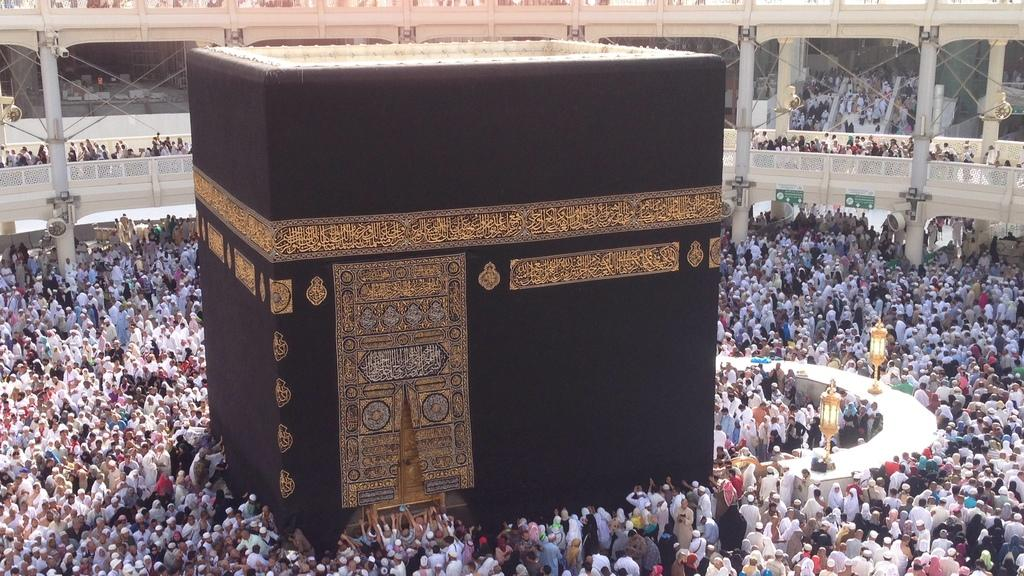What is the perspective of the image? The image is taken from inside. What shape is the wall visible in the image? There is a square-shaped wall in the image. How many people can be seen in the image? There are many people in the image. What type of lighting is present in the image? There are a few lamps present in the image. What type of foot is visible on the wall in the image? There is no foot visible on the wall in the image. What type of locket is being worn by the people in the image? There is no mention of a locket being worn by the people in the image. 